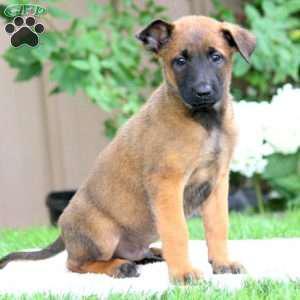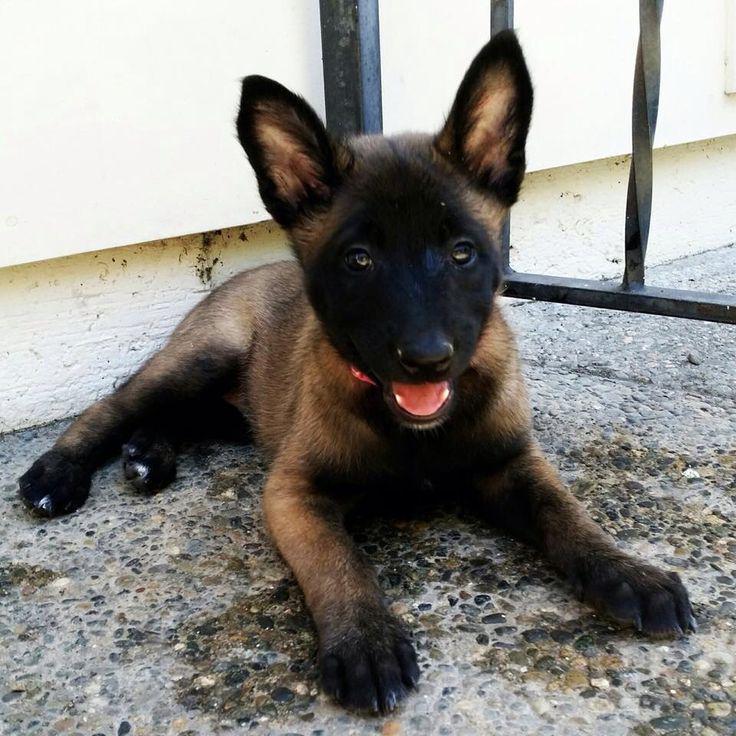The first image is the image on the left, the second image is the image on the right. Considering the images on both sides, is "One of the dogs is wearing a black collar." valid? Answer yes or no. No. 